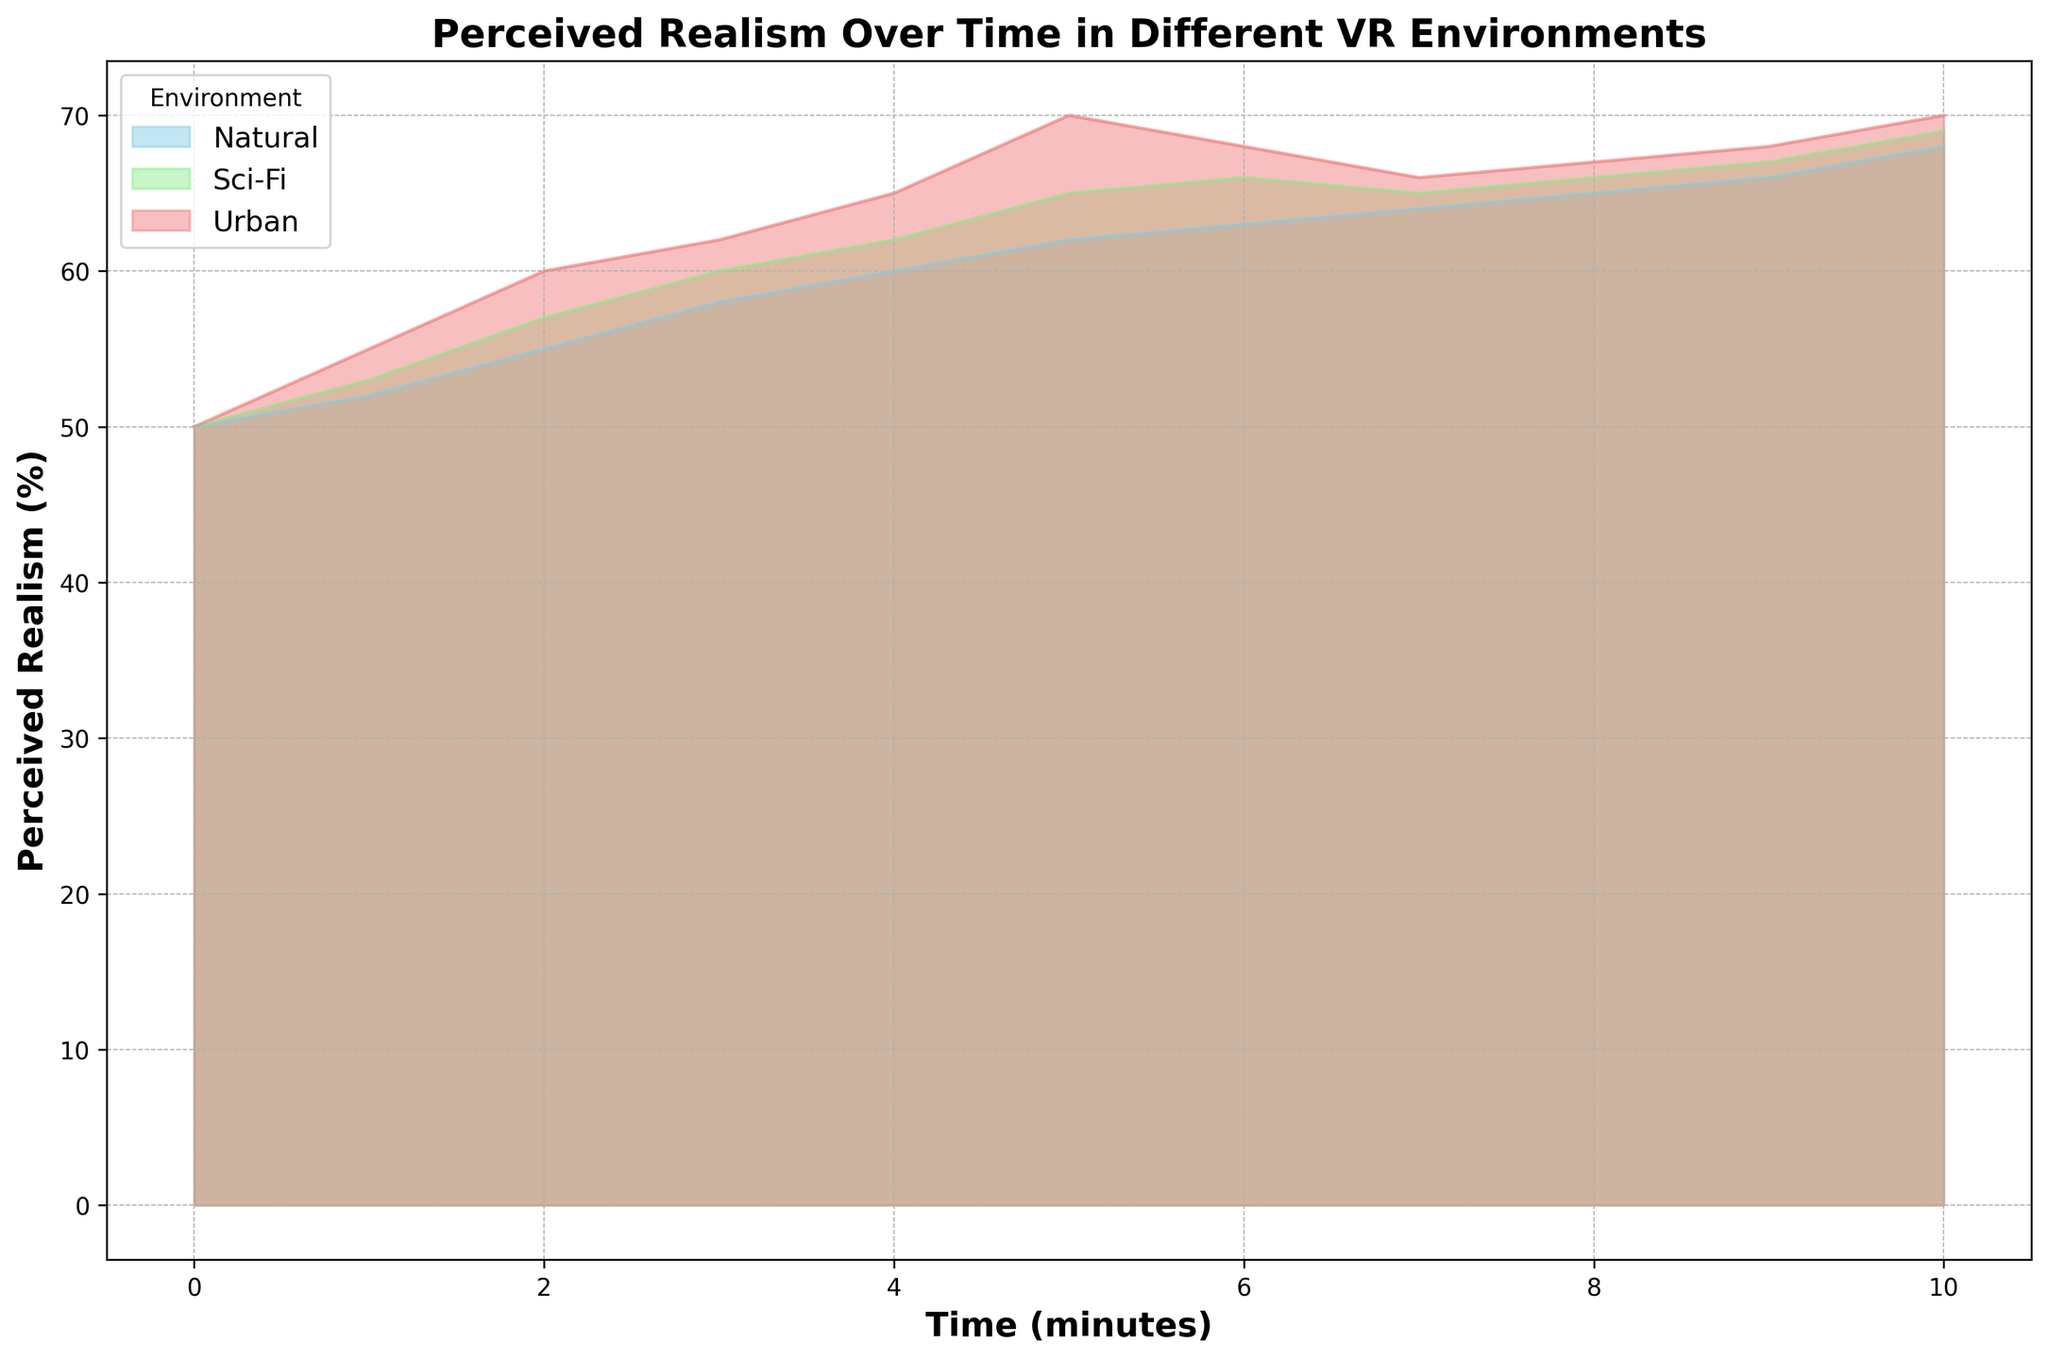What's the overall trend of perceived realism in the Urban environment over time? In the Urban environment, perceived realism increases from 50% to 70% within the first 10 minutes, with slight fluctuations after minute 6.
Answer: It generally increases At minute 5, which VR environment has the highest perceived realism? At minute 5, the Urban environment has a perceived realism of 70%, the highest among the environments.
Answer: Urban Compare the change in perceived realism between minutes 2 and 4 for the Sci-Fi and Natural environments. Which one had a greater increase? From minute 2 to minute 4, Sci-Fi increased from 57% to 62% (5% increase), while Natural increased from 55% to 60% (5% increase). They had equal increases.
Answer: Equal What is the perceived realism in the Natural environment at minute 7? At minute 7, the perceived realism in the Natural environment is 64%.
Answer: 64% Between minutes 6 and 8, which environment has the most stability in perceived realism, inferred by the least change in values? The Urban environment has values of 68%, 66%, and 67% between minutes 6 and 8, showing fluctuations in perceived realism compared to Sci-Fi (66%, 65%, 66%) and Natural (63%, 64%, 65%), indicating more stability.
Answer: Sci-Fi What is the average perceived realism at minute 10 across all environments? At minute 10, Urban has 70%, Natural has 68%, and Sci-Fi has 69%. The average is (70% + 68% + 69%) / 3 = 69%.
Answer: 69% Which environment has a consistently increasing perceived realism throughout the duration? The Natural environment has a consistently increasing perceived realism from 50% at minute 0 to 68% at minute 10, without any decline.
Answer: Natural At minute 5, what is the difference in perceived realism between Urban and Sci-Fi environments? At minute 5, Urban's perceived realism is 70%, while Sci-Fi's is 65%, so the difference is 70% - 65% = 5%.
Answer: 5% How does the perceived realism in the Natural environment at minute 0 compare to the Sci-Fi environment at minute 3 in terms of percentage difference? The Natural environment has 50% perceived realism at minute 0, and Sci-Fi has 60% at minute 3. The percentage difference is ((60 - 50) / 50) * 100% = 20%.
Answer: 20% Which environment has the highest perceived realism at any given time, and what is that value? The Urban environment has the highest perceived realism at minute 10, with a value of 70%.
Answer: Urban, 70% 